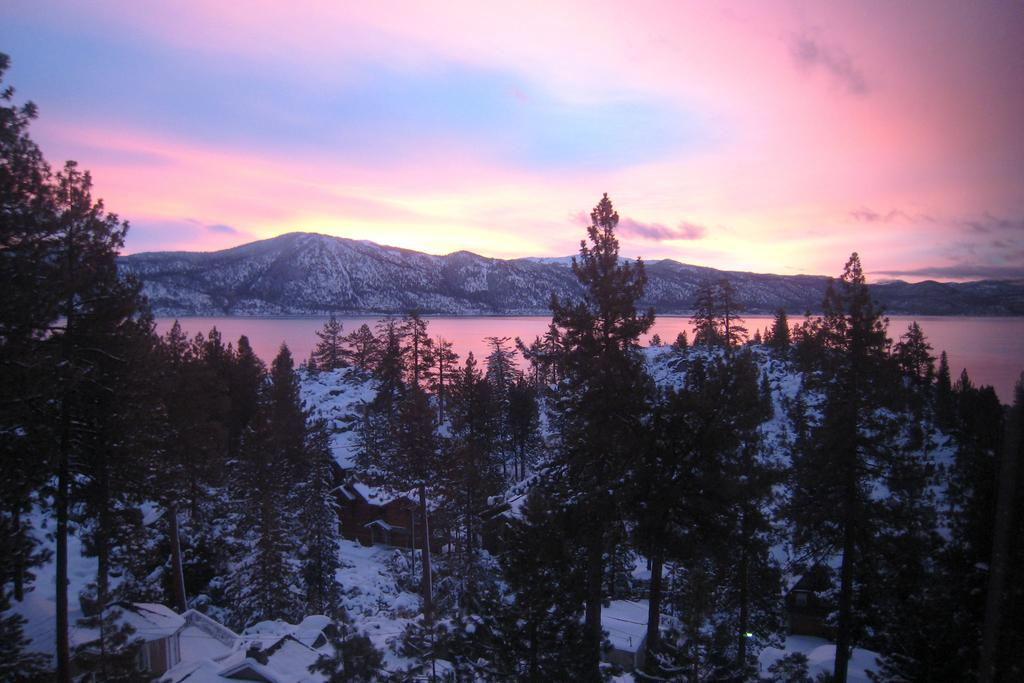What type of vegetation is visible in front of the image? There are trees in front of the image. What type of structures are visible in front of the image? There are houses in front of the image. What body of water is visible behind the houses? There is a river behind the houses. What geographical feature is visible on the other side of the river? There are mountains on the other side of the river. Can you see a goose swimming in the river in the image? There is no goose visible in the image; the focus is on the trees, houses, river, and mountains. What type of iron is used to construct the houses in the image? The provided facts do not mention any specific materials used to construct the houses, so we cannot determine if iron is used. 